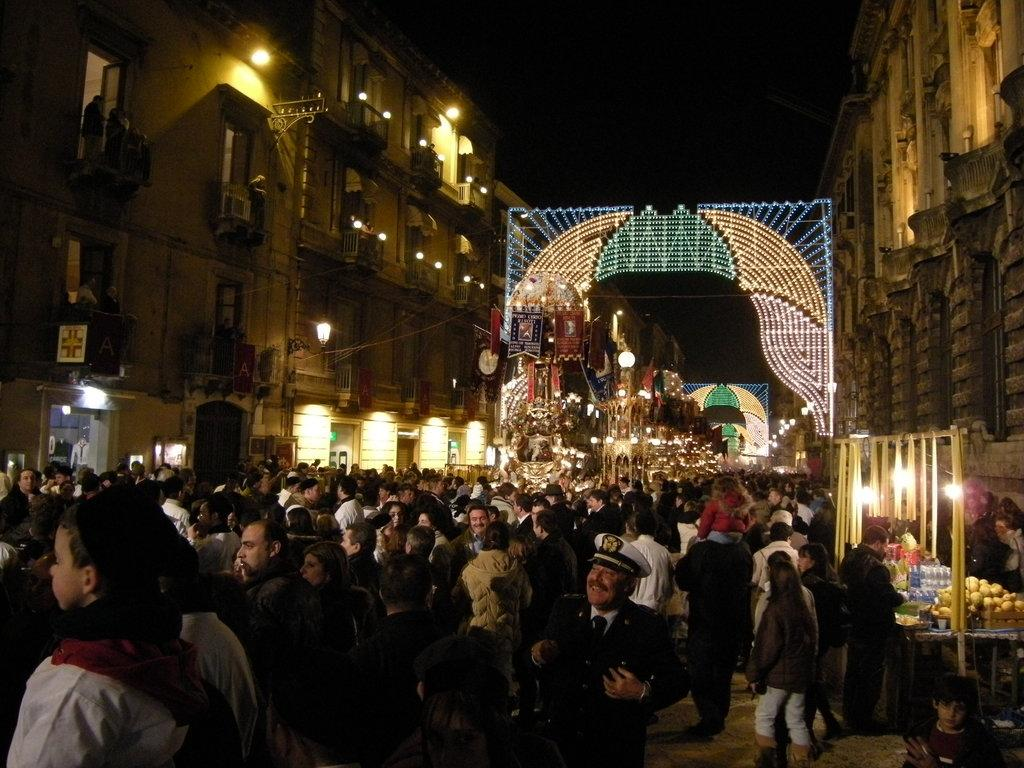What is happening with the group of people in the image? The group of people is on the ground in the image. What can be seen illuminating the scene in the image? There are lights visible in the image. What type of containers are present in the image? There are bottles in the image. What type of structures are visible in the image? There are buildings with windows in the image. Can you describe any other objects in the image? There are some objects in the image, but their specific details are not mentioned in the provided facts. How would you describe the overall lighting in the image? The background of the image is dark, which suggests that the lighting is low or dim. What type of snow can be seen falling in the image? There is no snow present in the image. What color is the marble table in the image? There is no marble table present in the image. 